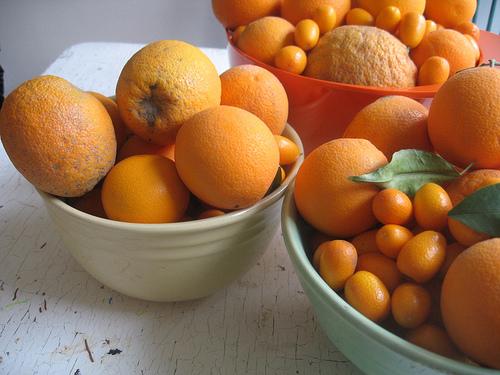What items in the bowls are inedible?
Be succinct. Leaves. What different kind of fruits is here?
Write a very short answer. Oranges. Does this look tasty?
Give a very brief answer. Yes. How many bowls are there?
Be succinct. 3. 